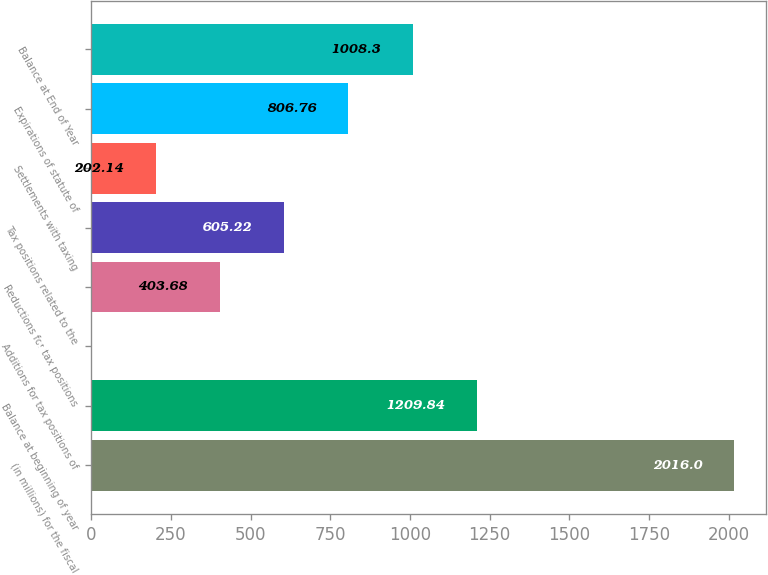<chart> <loc_0><loc_0><loc_500><loc_500><bar_chart><fcel>(in millions) for the fiscal<fcel>Balance at beginning of year<fcel>Additions for tax positions of<fcel>Reductions for tax positions<fcel>Tax positions related to the<fcel>Settlements with taxing<fcel>Expirations of statute of<fcel>Balance at End of Year<nl><fcel>2016<fcel>1209.84<fcel>0.6<fcel>403.68<fcel>605.22<fcel>202.14<fcel>806.76<fcel>1008.3<nl></chart> 